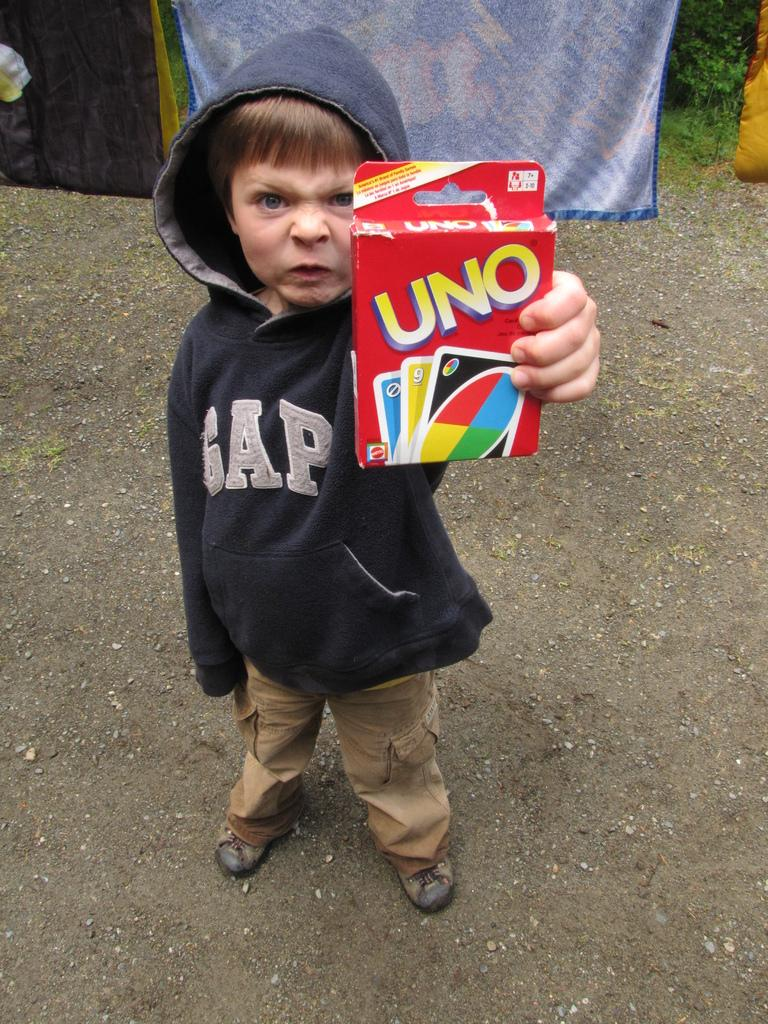Who is the main subject in the image? There is a boy in the center of the image. What is the boy doing in the image? The boy is standing on the ground and holding cards. What can be seen in the background of the image? There are clothes and trees visible in the background. Can you see a sponge floating in the ocean in the image? There is no ocean or sponge present in the image. Are the boy and another person exchanging a kiss in the image? There is no kiss or second person present in the image; it only features the boy holding cards. 